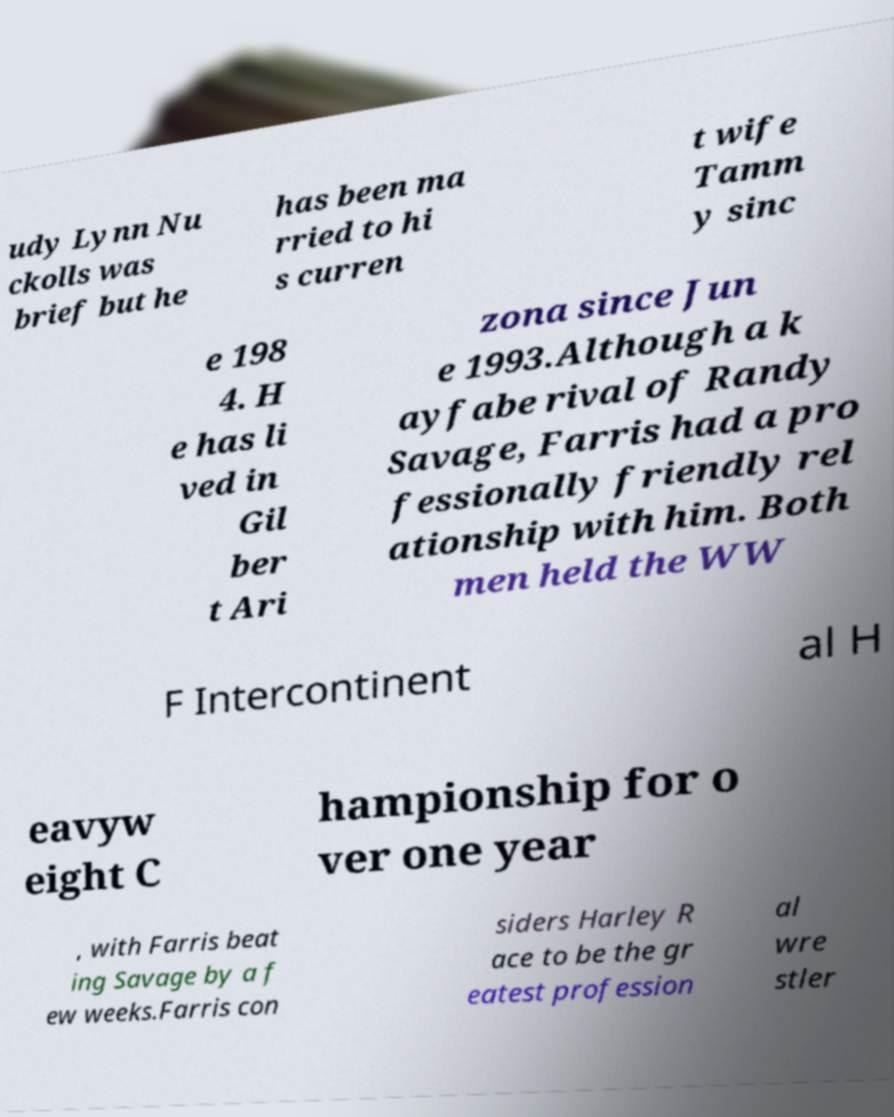Please read and relay the text visible in this image. What does it say? udy Lynn Nu ckolls was brief but he has been ma rried to hi s curren t wife Tamm y sinc e 198 4. H e has li ved in Gil ber t Ari zona since Jun e 1993.Although a k ayfabe rival of Randy Savage, Farris had a pro fessionally friendly rel ationship with him. Both men held the WW F Intercontinent al H eavyw eight C hampionship for o ver one year , with Farris beat ing Savage by a f ew weeks.Farris con siders Harley R ace to be the gr eatest profession al wre stler 